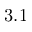Convert formula to latex. <formula><loc_0><loc_0><loc_500><loc_500>3 . 1</formula> 